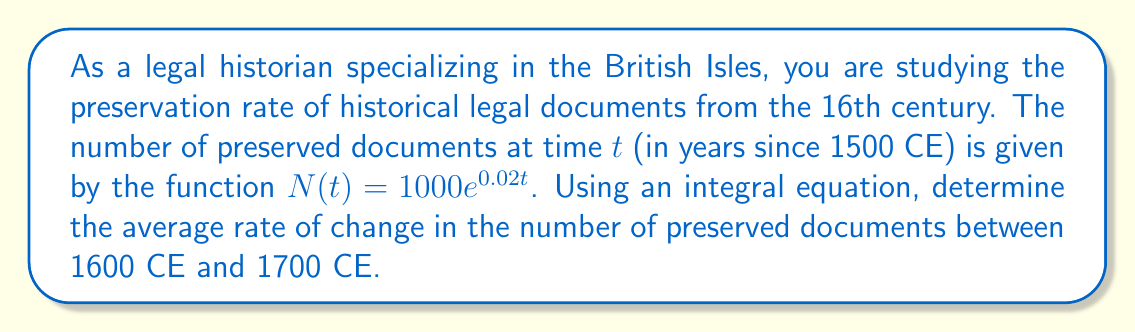Can you solve this math problem? To solve this problem, we'll follow these steps:

1) The average rate of change is given by the total change divided by the time interval. We can express this using an integral equation:

   $$\text{Average rate of change} = \frac{1}{b-a}\int_{a}^{b} \frac{dN}{dt} dt$$

   where $a$ and $b$ are the start and end times of our interval.

2) We need to find $\frac{dN}{dt}$. Given $N(t) = 1000e^{0.02t}$, we can differentiate:

   $$\frac{dN}{dt} = 1000 \cdot 0.02e^{0.02t} = 20e^{0.02t}$$

3) Now we can set up our integral equation:

   $$\text{Average rate of change} = \frac{1}{100-0}\int_{100}^{200} 20e^{0.02t} dt$$

4) Evaluate the integral:

   $$\frac{1}{100}\left[1000e^{0.02t}\right]_{100}^{200}$$

5) Substitute the limits:

   $$\frac{1}{100}(1000e^{4} - 1000e^{2})$$

6) Simplify:

   $$\frac{1000}{100}(e^{4} - e^{2}) \approx 403.43$$

Therefore, the average rate of change in the number of preserved documents between 1600 CE and 1700 CE is approximately 403.43 documents per year.
Answer: 403.43 documents/year 